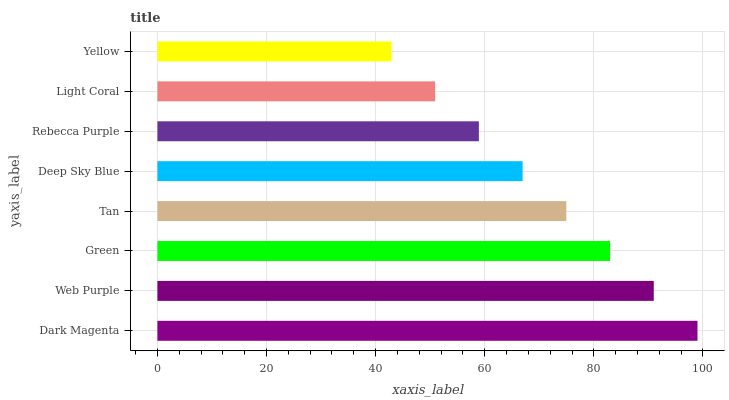Is Yellow the minimum?
Answer yes or no. Yes. Is Dark Magenta the maximum?
Answer yes or no. Yes. Is Web Purple the minimum?
Answer yes or no. No. Is Web Purple the maximum?
Answer yes or no. No. Is Dark Magenta greater than Web Purple?
Answer yes or no. Yes. Is Web Purple less than Dark Magenta?
Answer yes or no. Yes. Is Web Purple greater than Dark Magenta?
Answer yes or no. No. Is Dark Magenta less than Web Purple?
Answer yes or no. No. Is Tan the high median?
Answer yes or no. Yes. Is Deep Sky Blue the low median?
Answer yes or no. Yes. Is Light Coral the high median?
Answer yes or no. No. Is Dark Magenta the low median?
Answer yes or no. No. 